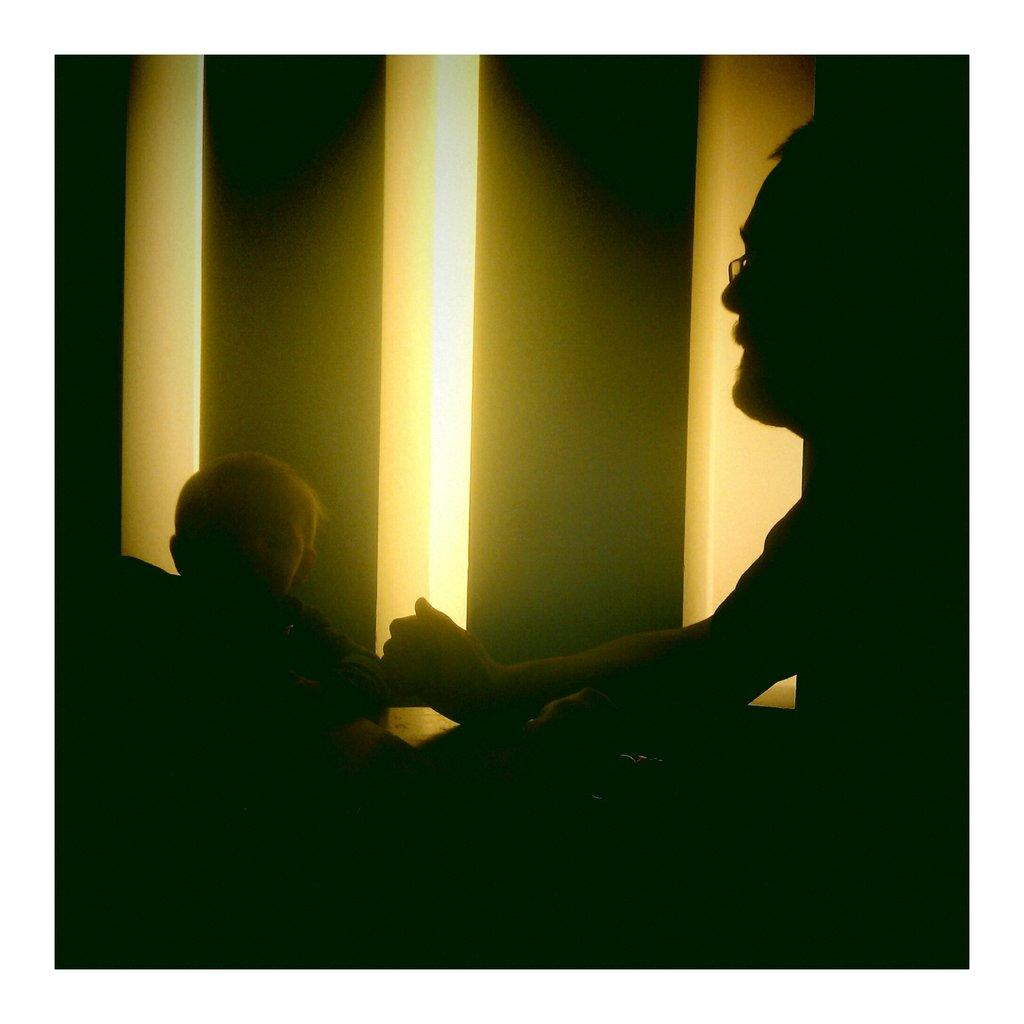Who is present in the image? There is a man and a boy in the image. What can be seen in the background of the image? There are pillars in the background of the image. What type of meat is being served on the table in the image? There is no table or meat present in the image; it only features a man, a boy, and pillars in the background. 